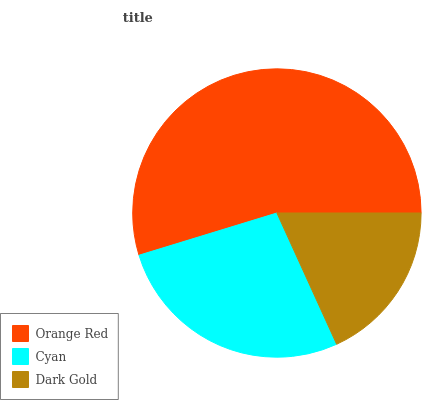Is Dark Gold the minimum?
Answer yes or no. Yes. Is Orange Red the maximum?
Answer yes or no. Yes. Is Cyan the minimum?
Answer yes or no. No. Is Cyan the maximum?
Answer yes or no. No. Is Orange Red greater than Cyan?
Answer yes or no. Yes. Is Cyan less than Orange Red?
Answer yes or no. Yes. Is Cyan greater than Orange Red?
Answer yes or no. No. Is Orange Red less than Cyan?
Answer yes or no. No. Is Cyan the high median?
Answer yes or no. Yes. Is Cyan the low median?
Answer yes or no. Yes. Is Dark Gold the high median?
Answer yes or no. No. Is Dark Gold the low median?
Answer yes or no. No. 